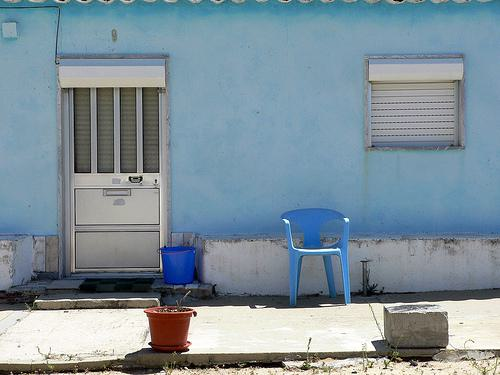Why might someone have placed only one chair outside this building? The placement of a single chair might imply that it is intended for personal use, possibly for relaxation or enjoying the outdoor ambiance, and there's not a frequent need for more seating in this area. Could this setup suggest anything about the social life of the person who lives here? This minimalistic setup might indicate a preference for solitude or a lack of frequent visitors, emphasizing a more reserved or private lifestyle. 